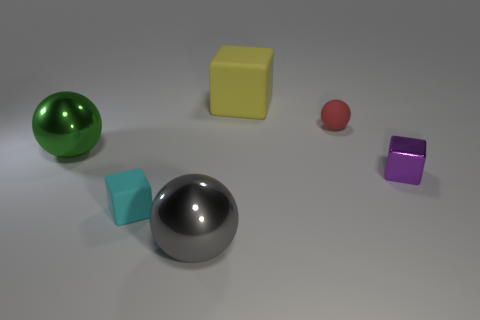How would you describe the lighting in this scene? The scene is softly lit with diffused lighting coming from above, creating gentle shadows underneath the objects. This type of lighting minimizes harsh contrasts and provides a calm, even distribution of light that enhances the visibility of the objects' textures and colors. 